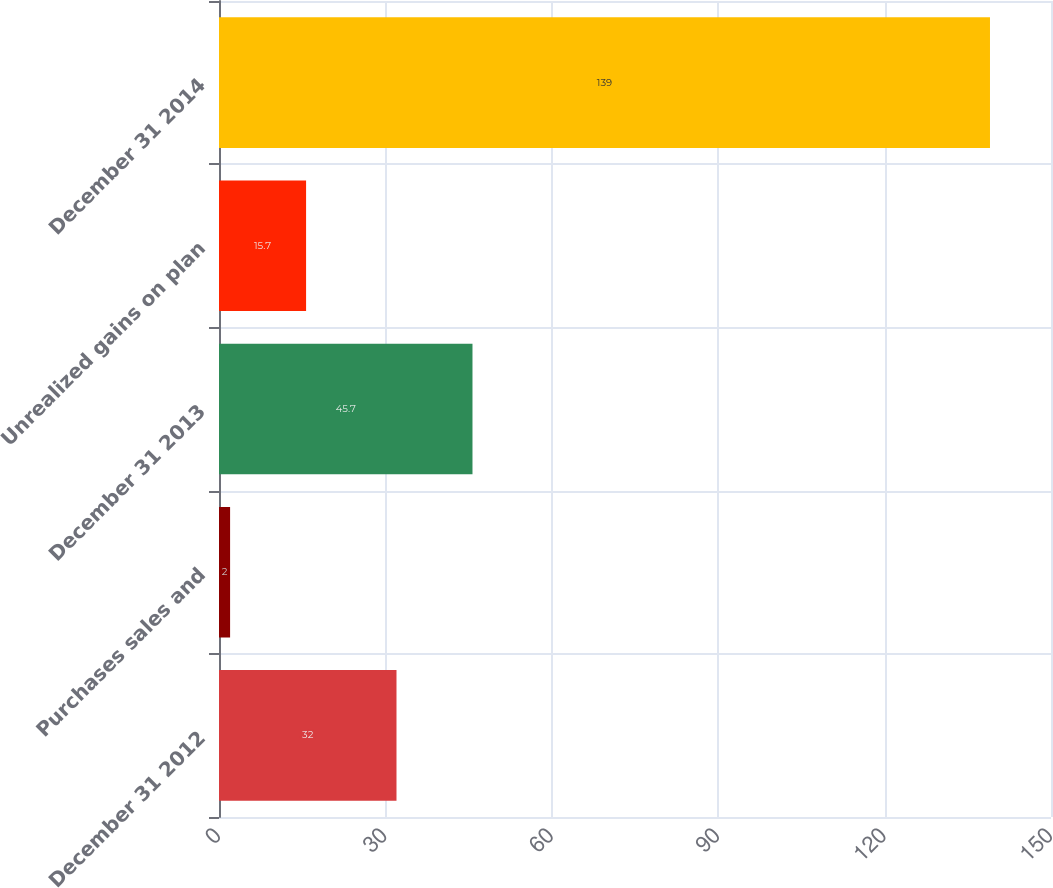Convert chart to OTSL. <chart><loc_0><loc_0><loc_500><loc_500><bar_chart><fcel>December 31 2012<fcel>Purchases sales and<fcel>December 31 2013<fcel>Unrealized gains on plan<fcel>December 31 2014<nl><fcel>32<fcel>2<fcel>45.7<fcel>15.7<fcel>139<nl></chart> 